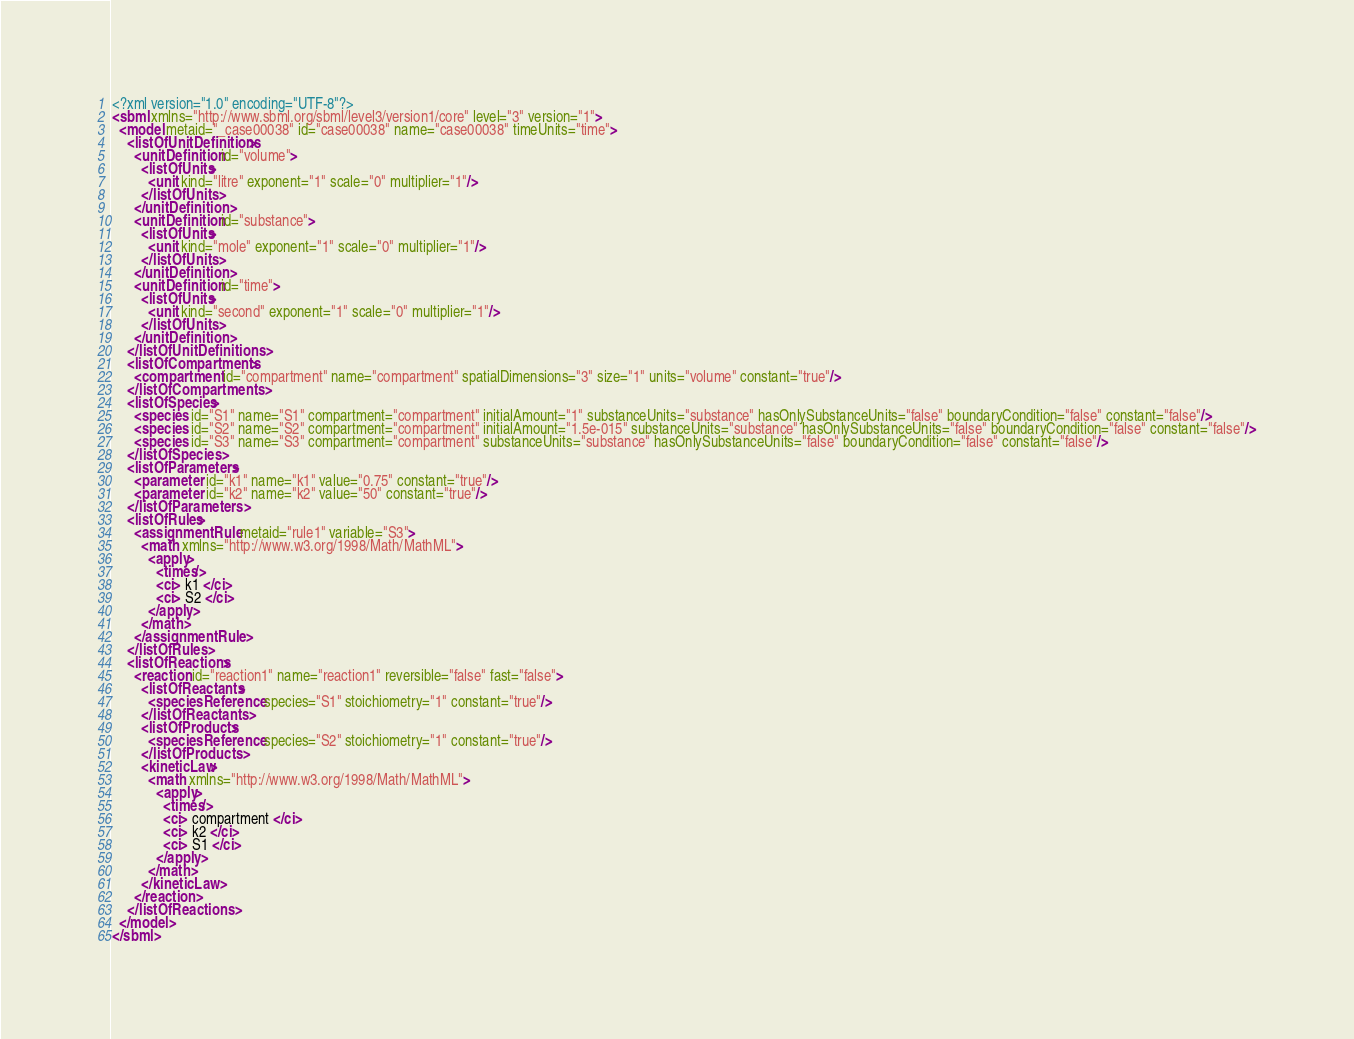Convert code to text. <code><loc_0><loc_0><loc_500><loc_500><_XML_><?xml version="1.0" encoding="UTF-8"?>
<sbml xmlns="http://www.sbml.org/sbml/level3/version1/core" level="3" version="1">
  <model metaid="_case00038" id="case00038" name="case00038" timeUnits="time">
    <listOfUnitDefinitions>
      <unitDefinition id="volume">
        <listOfUnits>
          <unit kind="litre" exponent="1" scale="0" multiplier="1"/>
        </listOfUnits>
      </unitDefinition>
      <unitDefinition id="substance">
        <listOfUnits>
          <unit kind="mole" exponent="1" scale="0" multiplier="1"/>
        </listOfUnits>
      </unitDefinition>
      <unitDefinition id="time">
        <listOfUnits>
          <unit kind="second" exponent="1" scale="0" multiplier="1"/>
        </listOfUnits>
      </unitDefinition>
    </listOfUnitDefinitions>
    <listOfCompartments>
      <compartment id="compartment" name="compartment" spatialDimensions="3" size="1" units="volume" constant="true"/>
    </listOfCompartments>
    <listOfSpecies>
      <species id="S1" name="S1" compartment="compartment" initialAmount="1" substanceUnits="substance" hasOnlySubstanceUnits="false" boundaryCondition="false" constant="false"/>
      <species id="S2" name="S2" compartment="compartment" initialAmount="1.5e-015" substanceUnits="substance" hasOnlySubstanceUnits="false" boundaryCondition="false" constant="false"/>
      <species id="S3" name="S3" compartment="compartment" substanceUnits="substance" hasOnlySubstanceUnits="false" boundaryCondition="false" constant="false"/>
    </listOfSpecies>
    <listOfParameters>
      <parameter id="k1" name="k1" value="0.75" constant="true"/>
      <parameter id="k2" name="k2" value="50" constant="true"/>
    </listOfParameters>
    <listOfRules>
      <assignmentRule metaid="rule1" variable="S3">
        <math xmlns="http://www.w3.org/1998/Math/MathML">
          <apply>
            <times/>
            <ci> k1 </ci>
            <ci> S2 </ci>
          </apply>
        </math>
      </assignmentRule>
    </listOfRules>
    <listOfReactions>
      <reaction id="reaction1" name="reaction1" reversible="false" fast="false">
        <listOfReactants>
          <speciesReference species="S1" stoichiometry="1" constant="true"/>
        </listOfReactants>
        <listOfProducts>
          <speciesReference species="S2" stoichiometry="1" constant="true"/>
        </listOfProducts>
        <kineticLaw>
          <math xmlns="http://www.w3.org/1998/Math/MathML">
            <apply>
              <times/>
              <ci> compartment </ci>
              <ci> k2 </ci>
              <ci> S1 </ci>
            </apply>
          </math>
        </kineticLaw>
      </reaction>
    </listOfReactions>
  </model>
</sbml>
</code> 